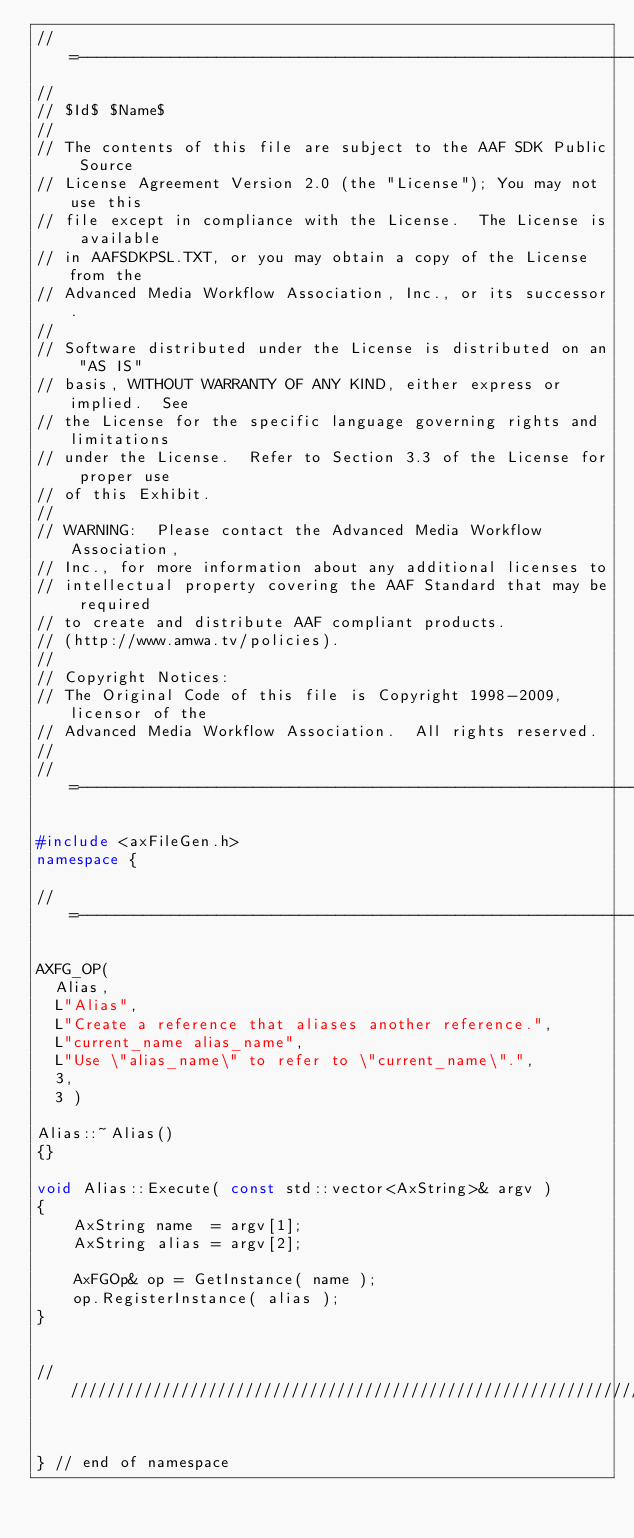<code> <loc_0><loc_0><loc_500><loc_500><_C++_>//=---------------------------------------------------------------------=
//
// $Id$ $Name$
//
// The contents of this file are subject to the AAF SDK Public Source
// License Agreement Version 2.0 (the "License"); You may not use this
// file except in compliance with the License.  The License is available
// in AAFSDKPSL.TXT, or you may obtain a copy of the License from the
// Advanced Media Workflow Association, Inc., or its successor.
//
// Software distributed under the License is distributed on an "AS IS"
// basis, WITHOUT WARRANTY OF ANY KIND, either express or implied.  See
// the License for the specific language governing rights and limitations
// under the License.  Refer to Section 3.3 of the License for proper use
// of this Exhibit.
//
// WARNING:  Please contact the Advanced Media Workflow Association,
// Inc., for more information about any additional licenses to
// intellectual property covering the AAF Standard that may be required
// to create and distribute AAF compliant products.
// (http://www.amwa.tv/policies).
//
// Copyright Notices:
// The Original Code of this file is Copyright 1998-2009, licensor of the
// Advanced Media Workflow Association.  All rights reserved.
//
//=---------------------------------------------------------------------=

#include <axFileGen.h>
namespace {

//=---------------------------------------------------------------------=

AXFG_OP(
  Alias,           
  L"Alias",
  L"Create a reference that aliases another reference.",
  L"current_name alias_name",
  L"Use \"alias_name\" to refer to \"current_name\".",
  3,
  3 ) 

Alias::~Alias()
{}

void Alias::Execute( const std::vector<AxString>& argv )
{
	AxString name  = argv[1];
	AxString alias = argv[2];

	AxFGOp& op = GetInstance( name );
	op.RegisterInstance( alias );
}


///////////////////////////////////////////////////////////////////////////


} // end of namespace


</code> 